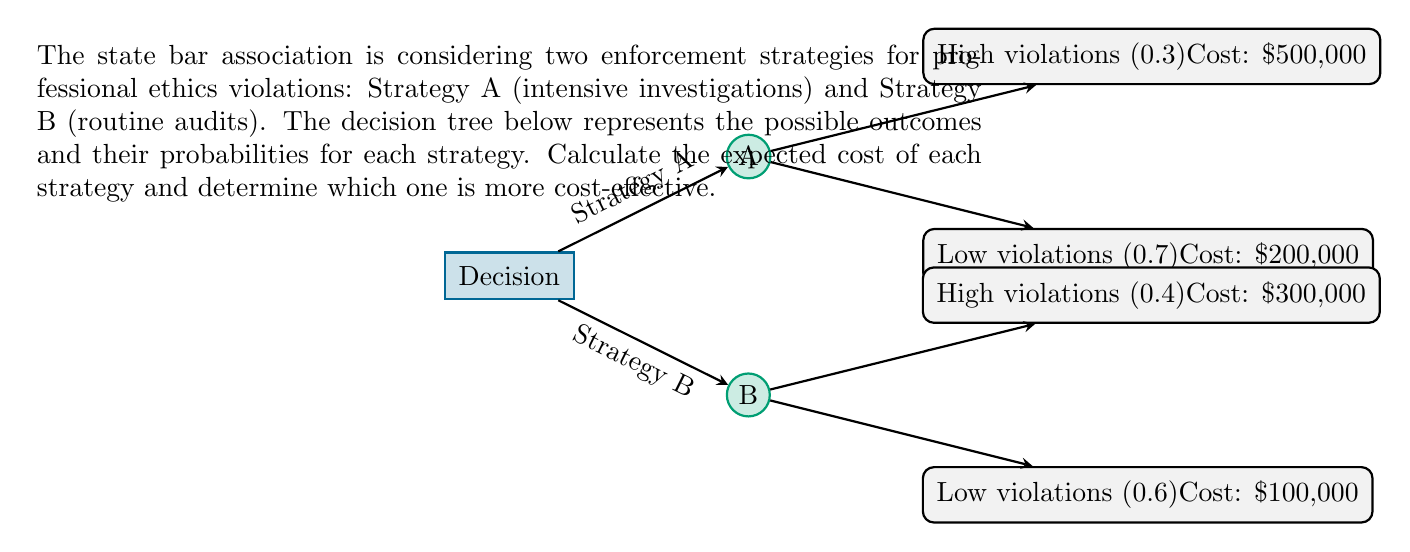Teach me how to tackle this problem. To determine the most cost-effective strategy, we need to calculate the expected cost for each strategy using the decision tree analysis.

1. Calculate the expected cost for Strategy A:
   - Probability of high violations: 0.3
   - Probability of low violations: 0.7
   - Cost of high violations: $500,000
   - Cost of low violations: $200,000

   Expected cost A = $(0.3 \times 500,000) + (0.7 \times 200,000)$
                   = $150,000 + 140,000$
                   = $290,000

2. Calculate the expected cost for Strategy B:
   - Probability of high violations: 0.4
   - Probability of low violations: 0.6
   - Cost of high violations: $300,000
   - Cost of low violations: $100,000

   Expected cost B = $(0.4 \times 300,000) + (0.6 \times 100,000)$
                   = $120,000 + 60,000$
                   = $180,000

3. Compare the expected costs:
   Strategy A: $290,000
   Strategy B: $180,000

   Strategy B has a lower expected cost, making it more cost-effective.
Answer: Strategy B is more cost-effective with an expected cost of $180,000. 